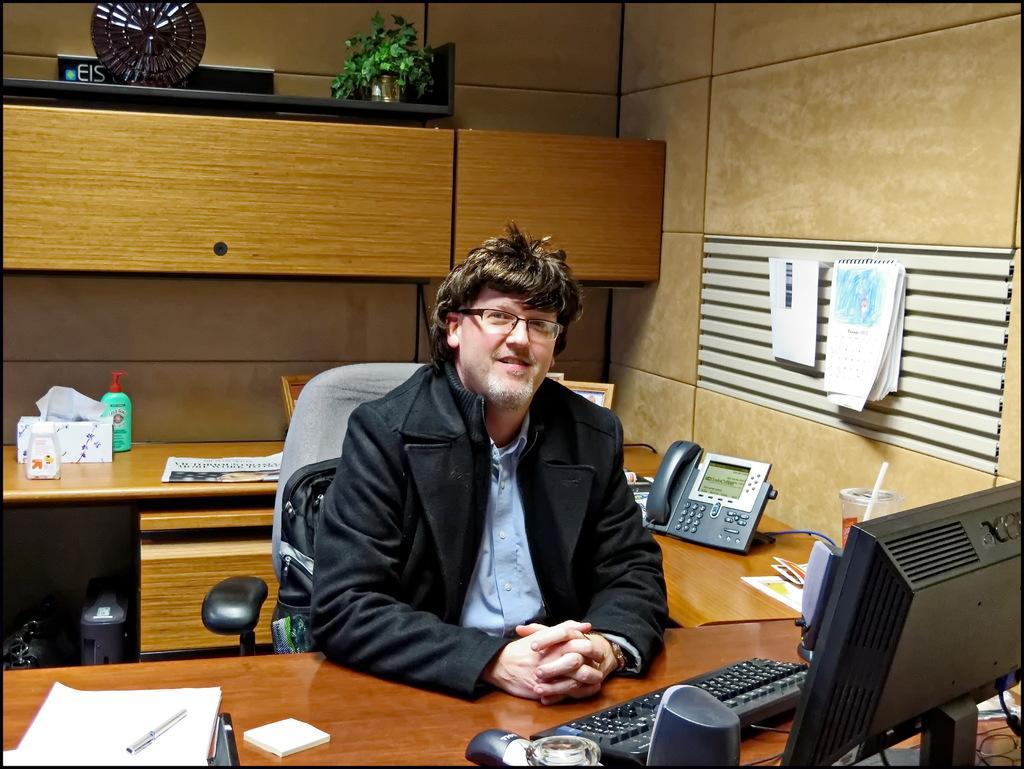In one or two sentences, can you explain what this image depicts? In this image I can see a man is sitting on a chair. On this table I can see few papers, a pen and a computer system. In the background I can see a telephone, a plant and few more stuffs. 